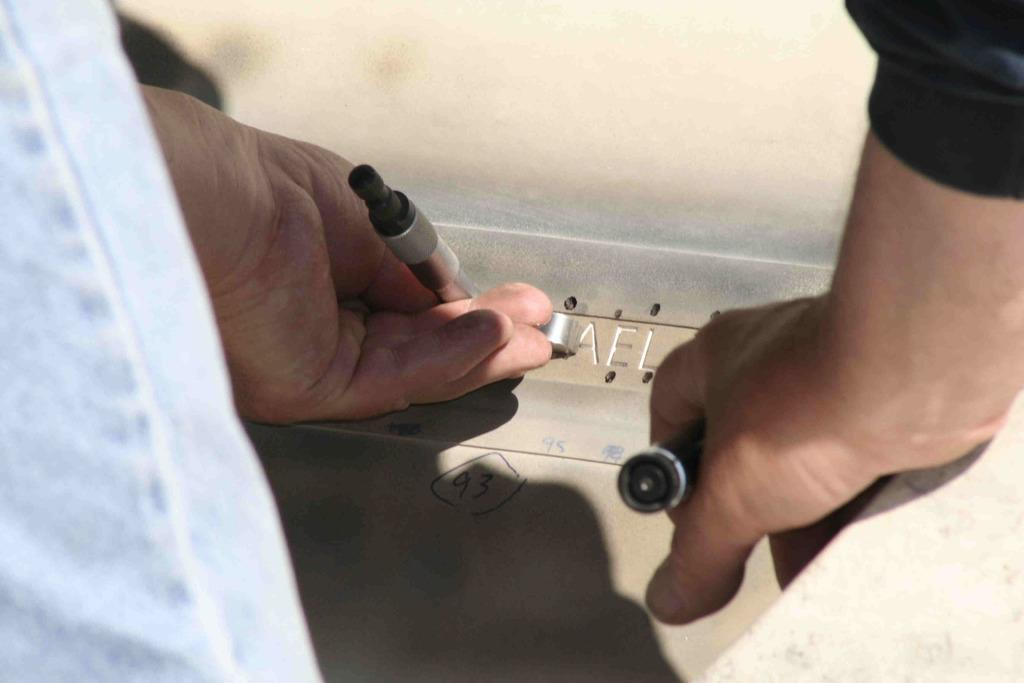What can be seen in the image involving human body parts? There are two hands in the image. What are the hands doing in the image? The hands are holding tools. What object is located in the center of the image? There is a piece of plywood in the center of the image. What type of quartz can be seen in the image? There is no quartz present in the image. What does the maid do in the image? There is no maid present in the image. 